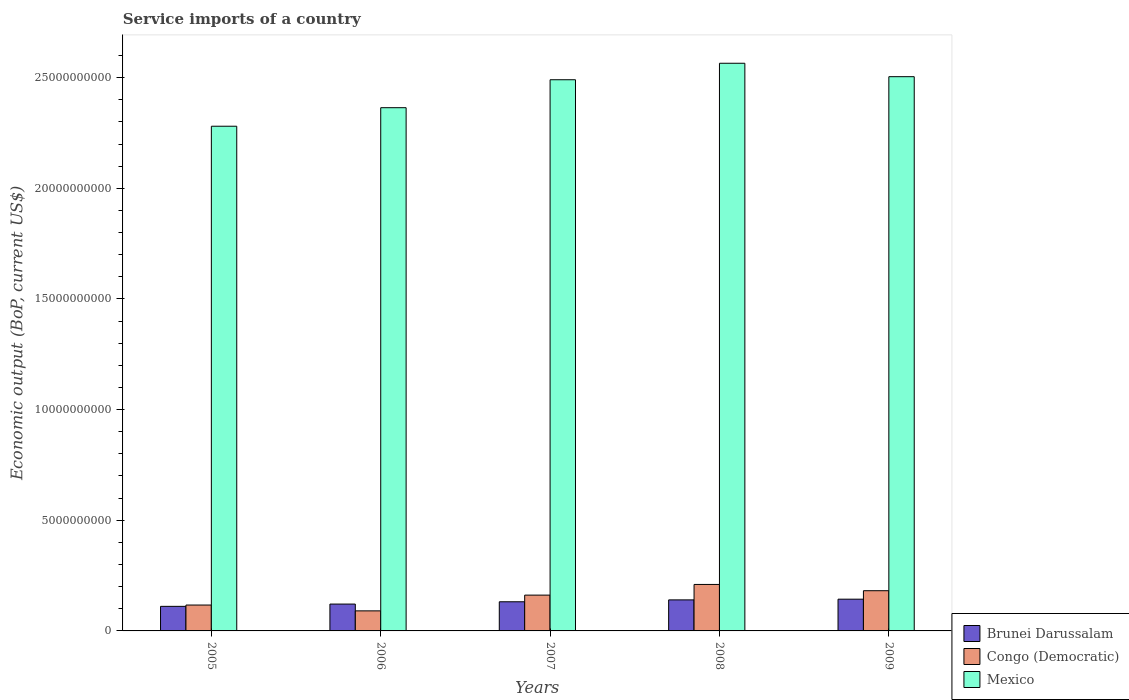How many bars are there on the 1st tick from the right?
Give a very brief answer. 3. What is the label of the 3rd group of bars from the left?
Your response must be concise. 2007. In how many cases, is the number of bars for a given year not equal to the number of legend labels?
Your response must be concise. 0. What is the service imports in Brunei Darussalam in 2006?
Offer a very short reply. 1.21e+09. Across all years, what is the maximum service imports in Mexico?
Ensure brevity in your answer.  2.56e+1. Across all years, what is the minimum service imports in Brunei Darussalam?
Ensure brevity in your answer.  1.11e+09. In which year was the service imports in Congo (Democratic) maximum?
Your answer should be compact. 2008. What is the total service imports in Congo (Democratic) in the graph?
Your answer should be compact. 7.61e+09. What is the difference between the service imports in Congo (Democratic) in 2007 and that in 2008?
Offer a terse response. -4.82e+08. What is the difference between the service imports in Mexico in 2009 and the service imports in Brunei Darussalam in 2006?
Your response must be concise. 2.38e+1. What is the average service imports in Congo (Democratic) per year?
Ensure brevity in your answer.  1.52e+09. In the year 2009, what is the difference between the service imports in Mexico and service imports in Brunei Darussalam?
Offer a terse response. 2.36e+1. In how many years, is the service imports in Mexico greater than 9000000000 US$?
Offer a very short reply. 5. What is the ratio of the service imports in Brunei Darussalam in 2007 to that in 2009?
Your answer should be very brief. 0.92. What is the difference between the highest and the second highest service imports in Congo (Democratic)?
Give a very brief answer. 2.82e+08. What is the difference between the highest and the lowest service imports in Mexico?
Offer a very short reply. 2.84e+09. Is the sum of the service imports in Congo (Democratic) in 2008 and 2009 greater than the maximum service imports in Brunei Darussalam across all years?
Offer a very short reply. Yes. Is it the case that in every year, the sum of the service imports in Mexico and service imports in Brunei Darussalam is greater than the service imports in Congo (Democratic)?
Provide a short and direct response. Yes. Are the values on the major ticks of Y-axis written in scientific E-notation?
Your response must be concise. No. Does the graph contain any zero values?
Provide a short and direct response. No. Does the graph contain grids?
Provide a short and direct response. No. How are the legend labels stacked?
Offer a terse response. Vertical. What is the title of the graph?
Your answer should be compact. Service imports of a country. Does "Sub-Saharan Africa (all income levels)" appear as one of the legend labels in the graph?
Your answer should be compact. No. What is the label or title of the Y-axis?
Your response must be concise. Economic output (BoP, current US$). What is the Economic output (BoP, current US$) in Brunei Darussalam in 2005?
Offer a very short reply. 1.11e+09. What is the Economic output (BoP, current US$) of Congo (Democratic) in 2005?
Provide a succinct answer. 1.17e+09. What is the Economic output (BoP, current US$) of Mexico in 2005?
Offer a terse response. 2.28e+1. What is the Economic output (BoP, current US$) in Brunei Darussalam in 2006?
Your response must be concise. 1.21e+09. What is the Economic output (BoP, current US$) of Congo (Democratic) in 2006?
Ensure brevity in your answer.  9.06e+08. What is the Economic output (BoP, current US$) of Mexico in 2006?
Provide a succinct answer. 2.36e+1. What is the Economic output (BoP, current US$) in Brunei Darussalam in 2007?
Keep it short and to the point. 1.32e+09. What is the Economic output (BoP, current US$) in Congo (Democratic) in 2007?
Give a very brief answer. 1.62e+09. What is the Economic output (BoP, current US$) in Mexico in 2007?
Make the answer very short. 2.49e+1. What is the Economic output (BoP, current US$) of Brunei Darussalam in 2008?
Offer a terse response. 1.40e+09. What is the Economic output (BoP, current US$) in Congo (Democratic) in 2008?
Make the answer very short. 2.10e+09. What is the Economic output (BoP, current US$) of Mexico in 2008?
Give a very brief answer. 2.56e+1. What is the Economic output (BoP, current US$) in Brunei Darussalam in 2009?
Give a very brief answer. 1.43e+09. What is the Economic output (BoP, current US$) in Congo (Democratic) in 2009?
Provide a succinct answer. 1.82e+09. What is the Economic output (BoP, current US$) in Mexico in 2009?
Make the answer very short. 2.50e+1. Across all years, what is the maximum Economic output (BoP, current US$) in Brunei Darussalam?
Provide a succinct answer. 1.43e+09. Across all years, what is the maximum Economic output (BoP, current US$) in Congo (Democratic)?
Offer a terse response. 2.10e+09. Across all years, what is the maximum Economic output (BoP, current US$) in Mexico?
Keep it short and to the point. 2.56e+1. Across all years, what is the minimum Economic output (BoP, current US$) of Brunei Darussalam?
Provide a short and direct response. 1.11e+09. Across all years, what is the minimum Economic output (BoP, current US$) in Congo (Democratic)?
Give a very brief answer. 9.06e+08. Across all years, what is the minimum Economic output (BoP, current US$) in Mexico?
Make the answer very short. 2.28e+1. What is the total Economic output (BoP, current US$) in Brunei Darussalam in the graph?
Provide a succinct answer. 6.48e+09. What is the total Economic output (BoP, current US$) in Congo (Democratic) in the graph?
Offer a very short reply. 7.61e+09. What is the total Economic output (BoP, current US$) in Mexico in the graph?
Your answer should be very brief. 1.22e+11. What is the difference between the Economic output (BoP, current US$) in Brunei Darussalam in 2005 and that in 2006?
Your answer should be very brief. -1.03e+08. What is the difference between the Economic output (BoP, current US$) of Congo (Democratic) in 2005 and that in 2006?
Your response must be concise. 2.63e+08. What is the difference between the Economic output (BoP, current US$) in Mexico in 2005 and that in 2006?
Offer a terse response. -8.37e+08. What is the difference between the Economic output (BoP, current US$) in Brunei Darussalam in 2005 and that in 2007?
Give a very brief answer. -2.07e+08. What is the difference between the Economic output (BoP, current US$) of Congo (Democratic) in 2005 and that in 2007?
Your response must be concise. -4.48e+08. What is the difference between the Economic output (BoP, current US$) of Mexico in 2005 and that in 2007?
Offer a terse response. -2.10e+09. What is the difference between the Economic output (BoP, current US$) in Brunei Darussalam in 2005 and that in 2008?
Provide a succinct answer. -2.92e+08. What is the difference between the Economic output (BoP, current US$) in Congo (Democratic) in 2005 and that in 2008?
Provide a succinct answer. -9.30e+08. What is the difference between the Economic output (BoP, current US$) in Mexico in 2005 and that in 2008?
Give a very brief answer. -2.84e+09. What is the difference between the Economic output (BoP, current US$) in Brunei Darussalam in 2005 and that in 2009?
Offer a terse response. -3.24e+08. What is the difference between the Economic output (BoP, current US$) of Congo (Democratic) in 2005 and that in 2009?
Give a very brief answer. -6.48e+08. What is the difference between the Economic output (BoP, current US$) in Mexico in 2005 and that in 2009?
Keep it short and to the point. -2.24e+09. What is the difference between the Economic output (BoP, current US$) of Brunei Darussalam in 2006 and that in 2007?
Offer a terse response. -1.03e+08. What is the difference between the Economic output (BoP, current US$) of Congo (Democratic) in 2006 and that in 2007?
Your answer should be very brief. -7.12e+08. What is the difference between the Economic output (BoP, current US$) in Mexico in 2006 and that in 2007?
Offer a very short reply. -1.26e+09. What is the difference between the Economic output (BoP, current US$) of Brunei Darussalam in 2006 and that in 2008?
Your response must be concise. -1.89e+08. What is the difference between the Economic output (BoP, current US$) of Congo (Democratic) in 2006 and that in 2008?
Your answer should be compact. -1.19e+09. What is the difference between the Economic output (BoP, current US$) in Mexico in 2006 and that in 2008?
Offer a terse response. -2.01e+09. What is the difference between the Economic output (BoP, current US$) of Brunei Darussalam in 2006 and that in 2009?
Your answer should be very brief. -2.21e+08. What is the difference between the Economic output (BoP, current US$) of Congo (Democratic) in 2006 and that in 2009?
Offer a terse response. -9.11e+08. What is the difference between the Economic output (BoP, current US$) in Mexico in 2006 and that in 2009?
Keep it short and to the point. -1.40e+09. What is the difference between the Economic output (BoP, current US$) of Brunei Darussalam in 2007 and that in 2008?
Make the answer very short. -8.57e+07. What is the difference between the Economic output (BoP, current US$) in Congo (Democratic) in 2007 and that in 2008?
Provide a short and direct response. -4.82e+08. What is the difference between the Economic output (BoP, current US$) in Mexico in 2007 and that in 2008?
Make the answer very short. -7.45e+08. What is the difference between the Economic output (BoP, current US$) in Brunei Darussalam in 2007 and that in 2009?
Offer a very short reply. -1.17e+08. What is the difference between the Economic output (BoP, current US$) of Congo (Democratic) in 2007 and that in 2009?
Provide a short and direct response. -2.00e+08. What is the difference between the Economic output (BoP, current US$) in Mexico in 2007 and that in 2009?
Your answer should be very brief. -1.38e+08. What is the difference between the Economic output (BoP, current US$) in Brunei Darussalam in 2008 and that in 2009?
Your response must be concise. -3.17e+07. What is the difference between the Economic output (BoP, current US$) in Congo (Democratic) in 2008 and that in 2009?
Ensure brevity in your answer.  2.82e+08. What is the difference between the Economic output (BoP, current US$) in Mexico in 2008 and that in 2009?
Provide a succinct answer. 6.06e+08. What is the difference between the Economic output (BoP, current US$) of Brunei Darussalam in 2005 and the Economic output (BoP, current US$) of Congo (Democratic) in 2006?
Provide a succinct answer. 2.04e+08. What is the difference between the Economic output (BoP, current US$) of Brunei Darussalam in 2005 and the Economic output (BoP, current US$) of Mexico in 2006?
Make the answer very short. -2.25e+1. What is the difference between the Economic output (BoP, current US$) of Congo (Democratic) in 2005 and the Economic output (BoP, current US$) of Mexico in 2006?
Offer a very short reply. -2.25e+1. What is the difference between the Economic output (BoP, current US$) of Brunei Darussalam in 2005 and the Economic output (BoP, current US$) of Congo (Democratic) in 2007?
Ensure brevity in your answer.  -5.07e+08. What is the difference between the Economic output (BoP, current US$) of Brunei Darussalam in 2005 and the Economic output (BoP, current US$) of Mexico in 2007?
Ensure brevity in your answer.  -2.38e+1. What is the difference between the Economic output (BoP, current US$) of Congo (Democratic) in 2005 and the Economic output (BoP, current US$) of Mexico in 2007?
Offer a very short reply. -2.37e+1. What is the difference between the Economic output (BoP, current US$) of Brunei Darussalam in 2005 and the Economic output (BoP, current US$) of Congo (Democratic) in 2008?
Your response must be concise. -9.89e+08. What is the difference between the Economic output (BoP, current US$) in Brunei Darussalam in 2005 and the Economic output (BoP, current US$) in Mexico in 2008?
Your answer should be compact. -2.45e+1. What is the difference between the Economic output (BoP, current US$) in Congo (Democratic) in 2005 and the Economic output (BoP, current US$) in Mexico in 2008?
Your answer should be compact. -2.45e+1. What is the difference between the Economic output (BoP, current US$) in Brunei Darussalam in 2005 and the Economic output (BoP, current US$) in Congo (Democratic) in 2009?
Provide a short and direct response. -7.07e+08. What is the difference between the Economic output (BoP, current US$) in Brunei Darussalam in 2005 and the Economic output (BoP, current US$) in Mexico in 2009?
Provide a succinct answer. -2.39e+1. What is the difference between the Economic output (BoP, current US$) in Congo (Democratic) in 2005 and the Economic output (BoP, current US$) in Mexico in 2009?
Offer a very short reply. -2.39e+1. What is the difference between the Economic output (BoP, current US$) in Brunei Darussalam in 2006 and the Economic output (BoP, current US$) in Congo (Democratic) in 2007?
Your answer should be very brief. -4.04e+08. What is the difference between the Economic output (BoP, current US$) in Brunei Darussalam in 2006 and the Economic output (BoP, current US$) in Mexico in 2007?
Make the answer very short. -2.37e+1. What is the difference between the Economic output (BoP, current US$) of Congo (Democratic) in 2006 and the Economic output (BoP, current US$) of Mexico in 2007?
Offer a very short reply. -2.40e+1. What is the difference between the Economic output (BoP, current US$) of Brunei Darussalam in 2006 and the Economic output (BoP, current US$) of Congo (Democratic) in 2008?
Make the answer very short. -8.86e+08. What is the difference between the Economic output (BoP, current US$) in Brunei Darussalam in 2006 and the Economic output (BoP, current US$) in Mexico in 2008?
Ensure brevity in your answer.  -2.44e+1. What is the difference between the Economic output (BoP, current US$) in Congo (Democratic) in 2006 and the Economic output (BoP, current US$) in Mexico in 2008?
Ensure brevity in your answer.  -2.47e+1. What is the difference between the Economic output (BoP, current US$) in Brunei Darussalam in 2006 and the Economic output (BoP, current US$) in Congo (Democratic) in 2009?
Make the answer very short. -6.04e+08. What is the difference between the Economic output (BoP, current US$) in Brunei Darussalam in 2006 and the Economic output (BoP, current US$) in Mexico in 2009?
Your answer should be compact. -2.38e+1. What is the difference between the Economic output (BoP, current US$) in Congo (Democratic) in 2006 and the Economic output (BoP, current US$) in Mexico in 2009?
Your answer should be very brief. -2.41e+1. What is the difference between the Economic output (BoP, current US$) in Brunei Darussalam in 2007 and the Economic output (BoP, current US$) in Congo (Democratic) in 2008?
Give a very brief answer. -7.83e+08. What is the difference between the Economic output (BoP, current US$) in Brunei Darussalam in 2007 and the Economic output (BoP, current US$) in Mexico in 2008?
Your response must be concise. -2.43e+1. What is the difference between the Economic output (BoP, current US$) of Congo (Democratic) in 2007 and the Economic output (BoP, current US$) of Mexico in 2008?
Your response must be concise. -2.40e+1. What is the difference between the Economic output (BoP, current US$) of Brunei Darussalam in 2007 and the Economic output (BoP, current US$) of Congo (Democratic) in 2009?
Your answer should be compact. -5.00e+08. What is the difference between the Economic output (BoP, current US$) of Brunei Darussalam in 2007 and the Economic output (BoP, current US$) of Mexico in 2009?
Ensure brevity in your answer.  -2.37e+1. What is the difference between the Economic output (BoP, current US$) of Congo (Democratic) in 2007 and the Economic output (BoP, current US$) of Mexico in 2009?
Keep it short and to the point. -2.34e+1. What is the difference between the Economic output (BoP, current US$) of Brunei Darussalam in 2008 and the Economic output (BoP, current US$) of Congo (Democratic) in 2009?
Offer a very short reply. -4.15e+08. What is the difference between the Economic output (BoP, current US$) of Brunei Darussalam in 2008 and the Economic output (BoP, current US$) of Mexico in 2009?
Provide a short and direct response. -2.36e+1. What is the difference between the Economic output (BoP, current US$) in Congo (Democratic) in 2008 and the Economic output (BoP, current US$) in Mexico in 2009?
Give a very brief answer. -2.29e+1. What is the average Economic output (BoP, current US$) of Brunei Darussalam per year?
Give a very brief answer. 1.30e+09. What is the average Economic output (BoP, current US$) in Congo (Democratic) per year?
Ensure brevity in your answer.  1.52e+09. What is the average Economic output (BoP, current US$) in Mexico per year?
Your answer should be compact. 2.44e+1. In the year 2005, what is the difference between the Economic output (BoP, current US$) in Brunei Darussalam and Economic output (BoP, current US$) in Congo (Democratic)?
Your answer should be very brief. -5.91e+07. In the year 2005, what is the difference between the Economic output (BoP, current US$) of Brunei Darussalam and Economic output (BoP, current US$) of Mexico?
Make the answer very short. -2.17e+1. In the year 2005, what is the difference between the Economic output (BoP, current US$) of Congo (Democratic) and Economic output (BoP, current US$) of Mexico?
Your answer should be compact. -2.16e+1. In the year 2006, what is the difference between the Economic output (BoP, current US$) in Brunei Darussalam and Economic output (BoP, current US$) in Congo (Democratic)?
Offer a very short reply. 3.08e+08. In the year 2006, what is the difference between the Economic output (BoP, current US$) in Brunei Darussalam and Economic output (BoP, current US$) in Mexico?
Make the answer very short. -2.24e+1. In the year 2006, what is the difference between the Economic output (BoP, current US$) in Congo (Democratic) and Economic output (BoP, current US$) in Mexico?
Provide a short and direct response. -2.27e+1. In the year 2007, what is the difference between the Economic output (BoP, current US$) of Brunei Darussalam and Economic output (BoP, current US$) of Congo (Democratic)?
Your answer should be very brief. -3.01e+08. In the year 2007, what is the difference between the Economic output (BoP, current US$) in Brunei Darussalam and Economic output (BoP, current US$) in Mexico?
Make the answer very short. -2.36e+1. In the year 2007, what is the difference between the Economic output (BoP, current US$) in Congo (Democratic) and Economic output (BoP, current US$) in Mexico?
Your answer should be very brief. -2.33e+1. In the year 2008, what is the difference between the Economic output (BoP, current US$) of Brunei Darussalam and Economic output (BoP, current US$) of Congo (Democratic)?
Make the answer very short. -6.97e+08. In the year 2008, what is the difference between the Economic output (BoP, current US$) of Brunei Darussalam and Economic output (BoP, current US$) of Mexico?
Offer a terse response. -2.42e+1. In the year 2008, what is the difference between the Economic output (BoP, current US$) in Congo (Democratic) and Economic output (BoP, current US$) in Mexico?
Offer a terse response. -2.35e+1. In the year 2009, what is the difference between the Economic output (BoP, current US$) of Brunei Darussalam and Economic output (BoP, current US$) of Congo (Democratic)?
Give a very brief answer. -3.83e+08. In the year 2009, what is the difference between the Economic output (BoP, current US$) in Brunei Darussalam and Economic output (BoP, current US$) in Mexico?
Your response must be concise. -2.36e+1. In the year 2009, what is the difference between the Economic output (BoP, current US$) in Congo (Democratic) and Economic output (BoP, current US$) in Mexico?
Make the answer very short. -2.32e+1. What is the ratio of the Economic output (BoP, current US$) of Brunei Darussalam in 2005 to that in 2006?
Your response must be concise. 0.91. What is the ratio of the Economic output (BoP, current US$) in Congo (Democratic) in 2005 to that in 2006?
Ensure brevity in your answer.  1.29. What is the ratio of the Economic output (BoP, current US$) of Mexico in 2005 to that in 2006?
Your response must be concise. 0.96. What is the ratio of the Economic output (BoP, current US$) in Brunei Darussalam in 2005 to that in 2007?
Your response must be concise. 0.84. What is the ratio of the Economic output (BoP, current US$) of Congo (Democratic) in 2005 to that in 2007?
Give a very brief answer. 0.72. What is the ratio of the Economic output (BoP, current US$) of Mexico in 2005 to that in 2007?
Your response must be concise. 0.92. What is the ratio of the Economic output (BoP, current US$) of Brunei Darussalam in 2005 to that in 2008?
Keep it short and to the point. 0.79. What is the ratio of the Economic output (BoP, current US$) in Congo (Democratic) in 2005 to that in 2008?
Your answer should be very brief. 0.56. What is the ratio of the Economic output (BoP, current US$) in Mexico in 2005 to that in 2008?
Ensure brevity in your answer.  0.89. What is the ratio of the Economic output (BoP, current US$) in Brunei Darussalam in 2005 to that in 2009?
Your response must be concise. 0.77. What is the ratio of the Economic output (BoP, current US$) in Congo (Democratic) in 2005 to that in 2009?
Your response must be concise. 0.64. What is the ratio of the Economic output (BoP, current US$) in Mexico in 2005 to that in 2009?
Provide a succinct answer. 0.91. What is the ratio of the Economic output (BoP, current US$) in Brunei Darussalam in 2006 to that in 2007?
Make the answer very short. 0.92. What is the ratio of the Economic output (BoP, current US$) of Congo (Democratic) in 2006 to that in 2007?
Offer a very short reply. 0.56. What is the ratio of the Economic output (BoP, current US$) of Mexico in 2006 to that in 2007?
Ensure brevity in your answer.  0.95. What is the ratio of the Economic output (BoP, current US$) of Brunei Darussalam in 2006 to that in 2008?
Offer a very short reply. 0.87. What is the ratio of the Economic output (BoP, current US$) of Congo (Democratic) in 2006 to that in 2008?
Keep it short and to the point. 0.43. What is the ratio of the Economic output (BoP, current US$) in Mexico in 2006 to that in 2008?
Offer a terse response. 0.92. What is the ratio of the Economic output (BoP, current US$) in Brunei Darussalam in 2006 to that in 2009?
Offer a very short reply. 0.85. What is the ratio of the Economic output (BoP, current US$) of Congo (Democratic) in 2006 to that in 2009?
Offer a terse response. 0.5. What is the ratio of the Economic output (BoP, current US$) of Mexico in 2006 to that in 2009?
Make the answer very short. 0.94. What is the ratio of the Economic output (BoP, current US$) of Brunei Darussalam in 2007 to that in 2008?
Give a very brief answer. 0.94. What is the ratio of the Economic output (BoP, current US$) of Congo (Democratic) in 2007 to that in 2008?
Your answer should be very brief. 0.77. What is the ratio of the Economic output (BoP, current US$) in Brunei Darussalam in 2007 to that in 2009?
Offer a very short reply. 0.92. What is the ratio of the Economic output (BoP, current US$) of Congo (Democratic) in 2007 to that in 2009?
Ensure brevity in your answer.  0.89. What is the ratio of the Economic output (BoP, current US$) in Brunei Darussalam in 2008 to that in 2009?
Provide a succinct answer. 0.98. What is the ratio of the Economic output (BoP, current US$) of Congo (Democratic) in 2008 to that in 2009?
Keep it short and to the point. 1.16. What is the ratio of the Economic output (BoP, current US$) in Mexico in 2008 to that in 2009?
Provide a short and direct response. 1.02. What is the difference between the highest and the second highest Economic output (BoP, current US$) in Brunei Darussalam?
Your response must be concise. 3.17e+07. What is the difference between the highest and the second highest Economic output (BoP, current US$) in Congo (Democratic)?
Your response must be concise. 2.82e+08. What is the difference between the highest and the second highest Economic output (BoP, current US$) in Mexico?
Your response must be concise. 6.06e+08. What is the difference between the highest and the lowest Economic output (BoP, current US$) of Brunei Darussalam?
Your answer should be very brief. 3.24e+08. What is the difference between the highest and the lowest Economic output (BoP, current US$) in Congo (Democratic)?
Give a very brief answer. 1.19e+09. What is the difference between the highest and the lowest Economic output (BoP, current US$) in Mexico?
Offer a terse response. 2.84e+09. 